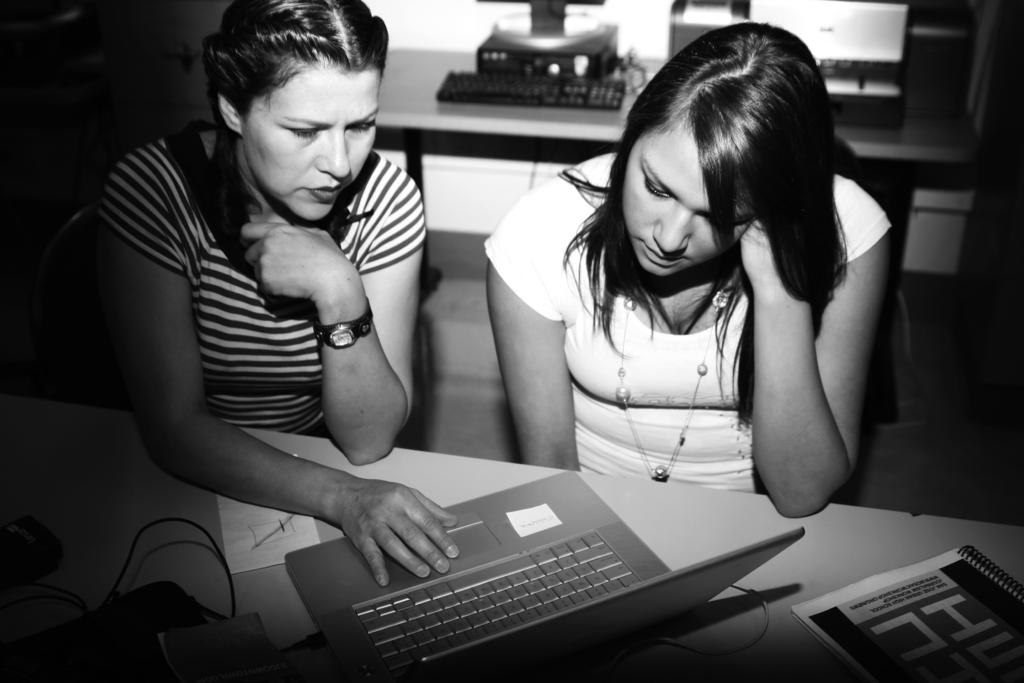How many people are sitting in the image? There are two people sitting in the image. What furniture is present in the image? There are chairs and tables in the image. What electronic devices can be seen in the image? There is a laptop, a monitor, a CPU, and a keyboard in the image. What type of document is present in the image? There is a file in the image. How many houses can be seen in the image? There are no houses visible in the image. What type of bean is being used to power the laptop in the image? There is no bean present in the image, and the laptop is not powered by a bean. 